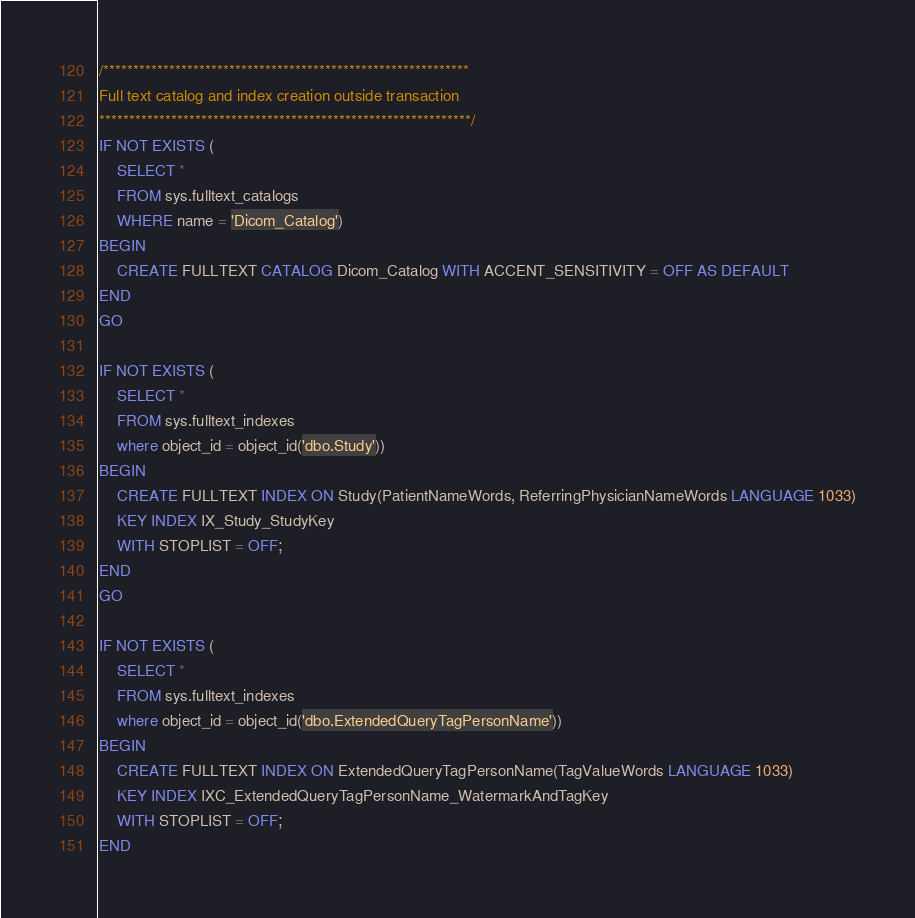<code> <loc_0><loc_0><loc_500><loc_500><_SQL_>/*************************************************************
Full text catalog and index creation outside transaction
**************************************************************/
IF NOT EXISTS (
    SELECT *
    FROM sys.fulltext_catalogs
    WHERE name = 'Dicom_Catalog')
BEGIN
    CREATE FULLTEXT CATALOG Dicom_Catalog WITH ACCENT_SENSITIVITY = OFF AS DEFAULT
END
GO

IF NOT EXISTS (
    SELECT *
    FROM sys.fulltext_indexes
    where object_id = object_id('dbo.Study'))
BEGIN
    CREATE FULLTEXT INDEX ON Study(PatientNameWords, ReferringPhysicianNameWords LANGUAGE 1033)
    KEY INDEX IX_Study_StudyKey
    WITH STOPLIST = OFF;
END
GO

IF NOT EXISTS (
    SELECT *
    FROM sys.fulltext_indexes
    where object_id = object_id('dbo.ExtendedQueryTagPersonName'))
BEGIN
    CREATE FULLTEXT INDEX ON ExtendedQueryTagPersonName(TagValueWords LANGUAGE 1033)
    KEY INDEX IXC_ExtendedQueryTagPersonName_WatermarkAndTagKey
    WITH STOPLIST = OFF;
END</code> 